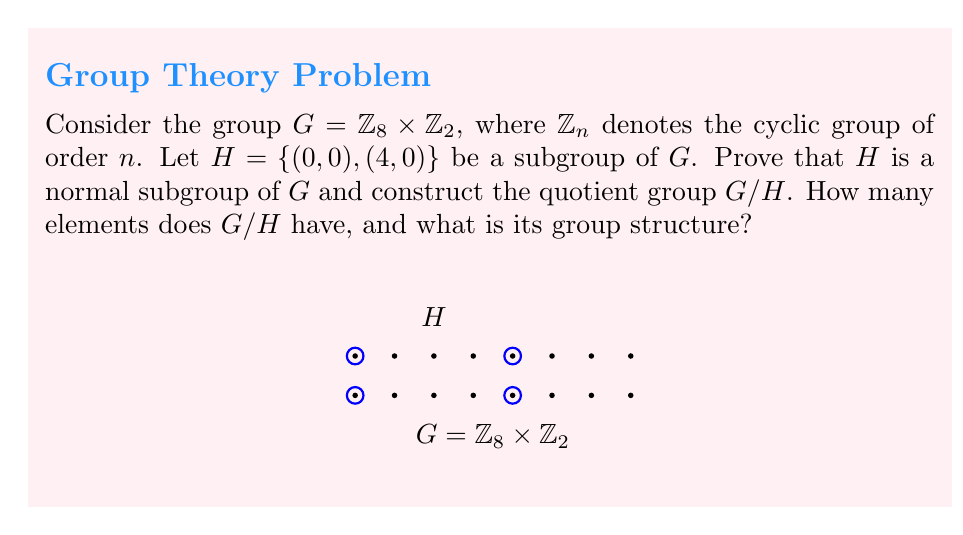Give your solution to this math problem. 1. First, we need to prove that $H$ is a normal subgroup of $G$:
   - $H$ is clearly a subgroup of $G$ as it contains the identity $(0,0)$ and is closed under the group operation.
   - To show $H$ is normal, we need to prove that $gHg^{-1} = H$ for all $g \in G$.
   - For any $(a,b) \in G$ and $(h,0) \in H$:
     $$(a,b) + (h,0) - (a,b) = (a+h-a \bmod 8, 0) = (h \bmod 8, 0)$$
   - This is always in $H$, so $H$ is normal in $G$.

2. To construct $G/H$, we need to find all the cosets of $H$ in $G$:
   - $G/H = \{(a,b) + H : (a,b) \in G\}$
   - The cosets are:
     $H = \{(0,0), (4,0)\}$
     $(1,0) + H = \{(1,0), (5,0)\}$
     $(2,0) + H = \{(2,0), (6,0)\}$
     $(3,0) + H = \{(3,0), (7,0)\}$
     $(0,1) + H = \{(0,1), (4,1)\}$
     $(1,1) + H = \{(1,1), (5,1)\}$
     $(2,1) + H = \{(2,1), (6,1)\}$
     $(3,1) + H = \{(3,1), (7,1)\}$

3. The number of elements in $G/H$ is $|G|/|H| = (8 \cdot 2) / 2 = 8$.

4. To determine the group structure of $G/H$:
   - Let $\bar{a} = (1,0) + H$ and $\bar{b} = (0,1) + H$.
   - We can see that $4\bar{a} = H$ (the identity in $G/H$) and $2\bar{b} = H$.
   - Also, $\bar{a} + \bar{b} = \bar{b} + \bar{a}$.
   - Therefore, $G/H \cong \mathbb{Z}_4 \times \mathbb{Z}_2$.
Answer: $G/H \cong \mathbb{Z}_4 \times \mathbb{Z}_2$, with 8 elements 